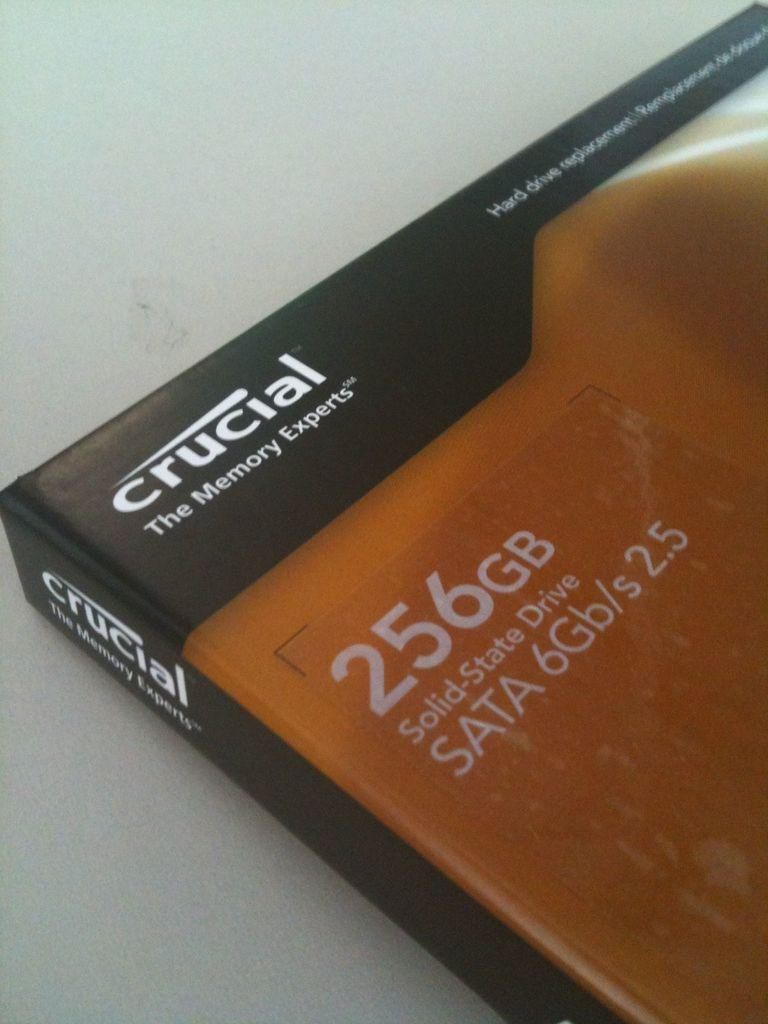<image>
Relay a brief, clear account of the picture shown. a crucial The Memory Experts Solid State Drive. 